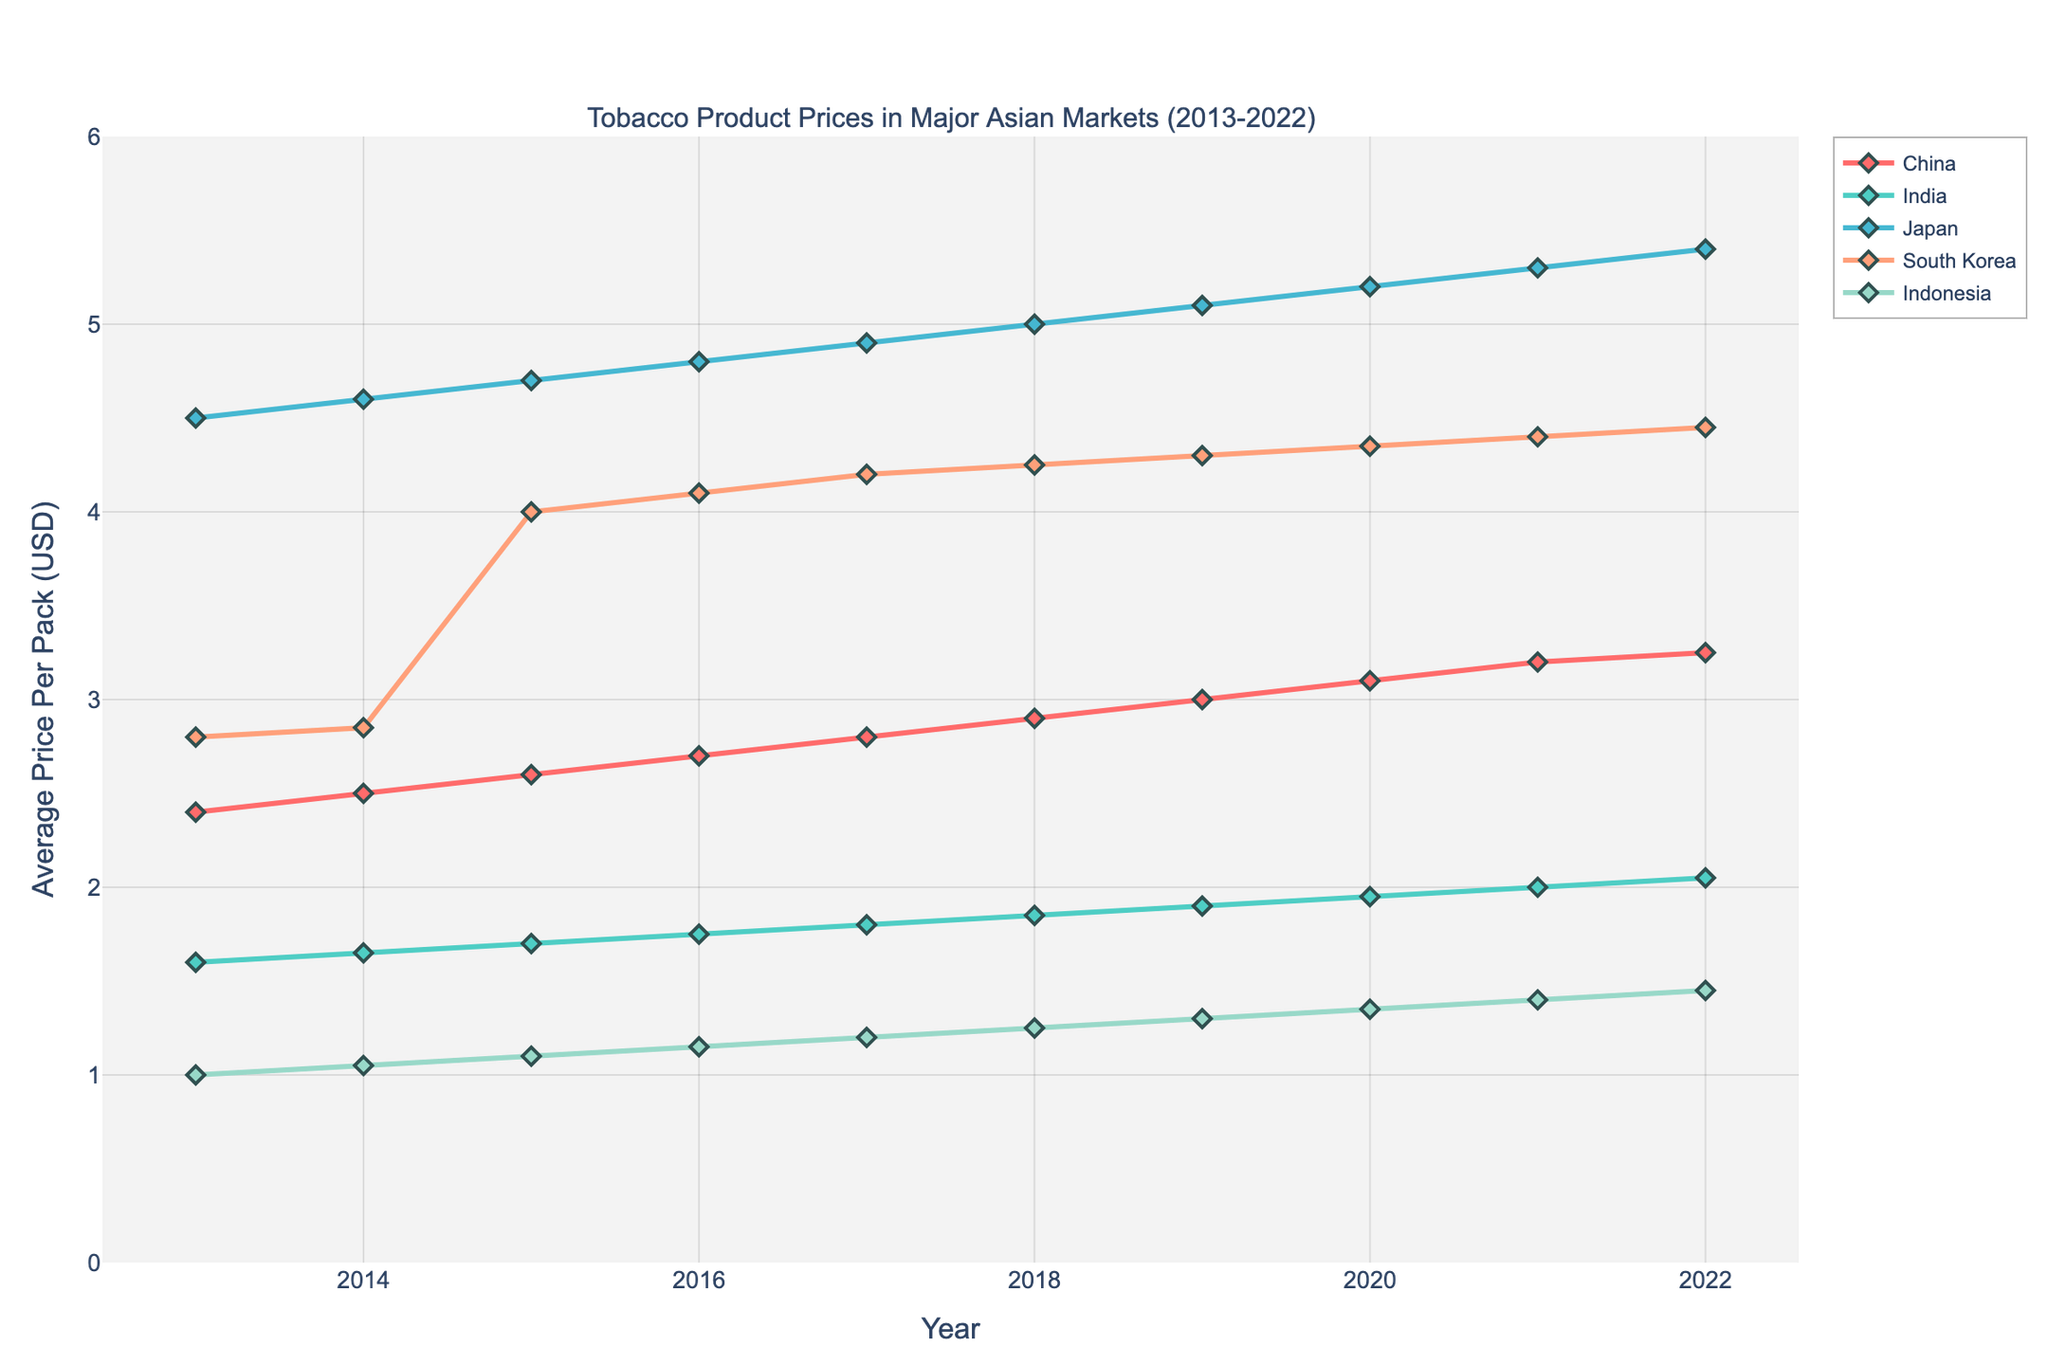What is the title of the plot? The title of the plot is located at the top and summarizes the content displayed in the figure. It reads "Tobacco Product Prices in Major Asian Markets (2013-2022)"
Answer: Tobacco Product Prices in Major Asian Markets (2013-2022) Which country had the lowest average price per pack in 2022? Look at the data points for 2022 and find the country with the lowest y-axis value. The lowest point corresponds to Indonesia.
Answer: Indonesia What is the average price per pack of cigarettes in Japan for the year 2018? Find the line corresponding to Japan and locate the data point for the year 2018. The y-axis value for this point indicates the price.
Answer: 5.00 Between 2014 and 2015, which country experienced the largest increase in average price per pack? Calculate the difference in price between 2014 and 2015 for each country. The largest increase is seen in South Korea (2.85 to 4.00).
Answer: South Korea How many countries are represented in the plot? Analyze the legend and the number of distinct lines/colors to determine the number of countries. There are five unique countries listed in the legend.
Answer: 5 Did the average price per pack in India ever reach $2.00 within the given time range? Examine the data points for India across the years. The value reaches $2.00 in 2021.
Answer: Yes By how much did the average price per pack in China increase from 2015 to 2022? Find the data points for China in 2015 and 2022, and subtract the 2015 value from the 2022 value (3.25 - 2.60).
Answer: 0.65 Which year shows the highest average price per pack for South Korea? Identify the peak data point on the South Korea line, which occurs in 2022.
Answer: 2022 Arrange the countries based on their average price per pack in 2013 from highest to lowest. Compare the y-axis values for all countries in 2013 and rank them as follows: Japan (4.50), South Korea (2.80), China (2.40), India (1.60), Indonesia (1.00).
Answer: Japan > South Korea > China > India > Indonesia 